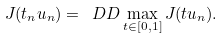<formula> <loc_0><loc_0><loc_500><loc_500>J ( t _ { n } u _ { n } ) = \ D D \max _ { t \in [ 0 , 1 ] } J ( t u _ { n } ) .</formula> 